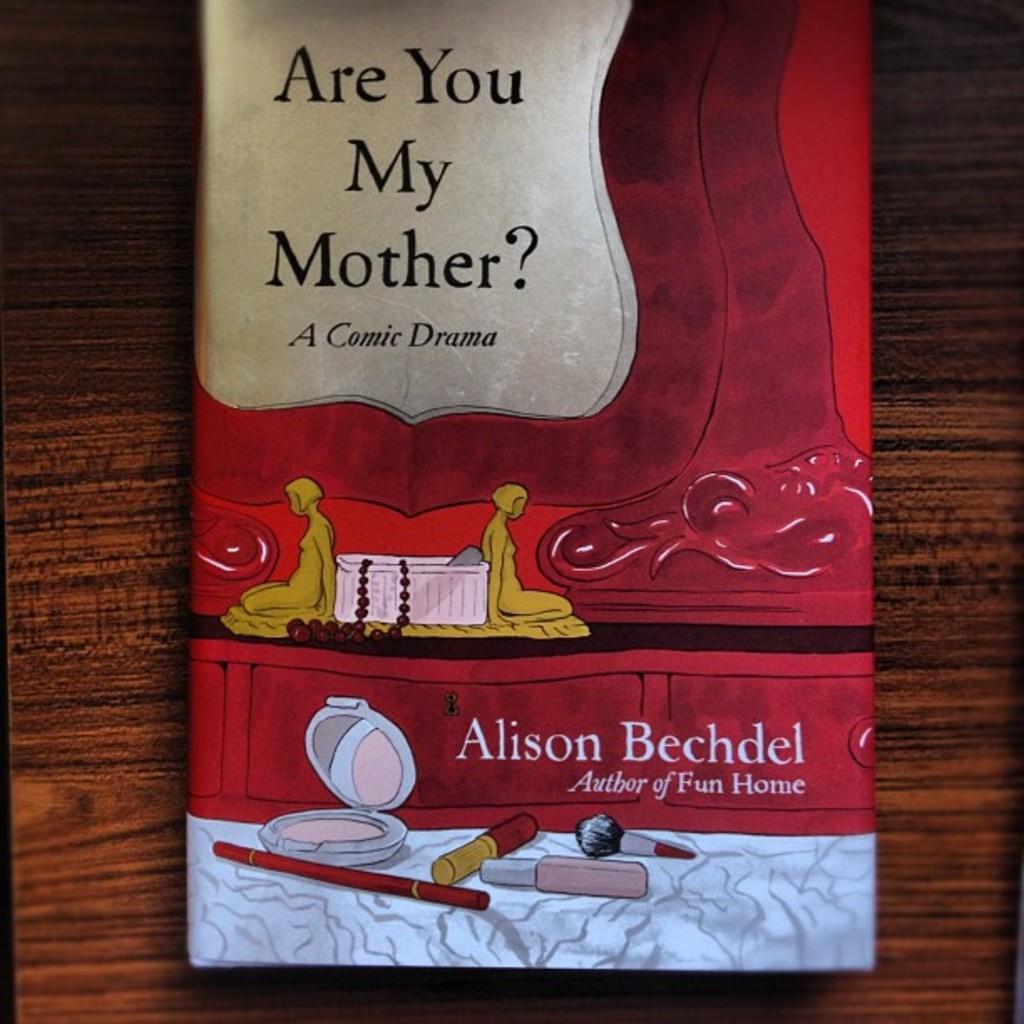What is the name of the book?
Make the answer very short. Are you my mother?. 